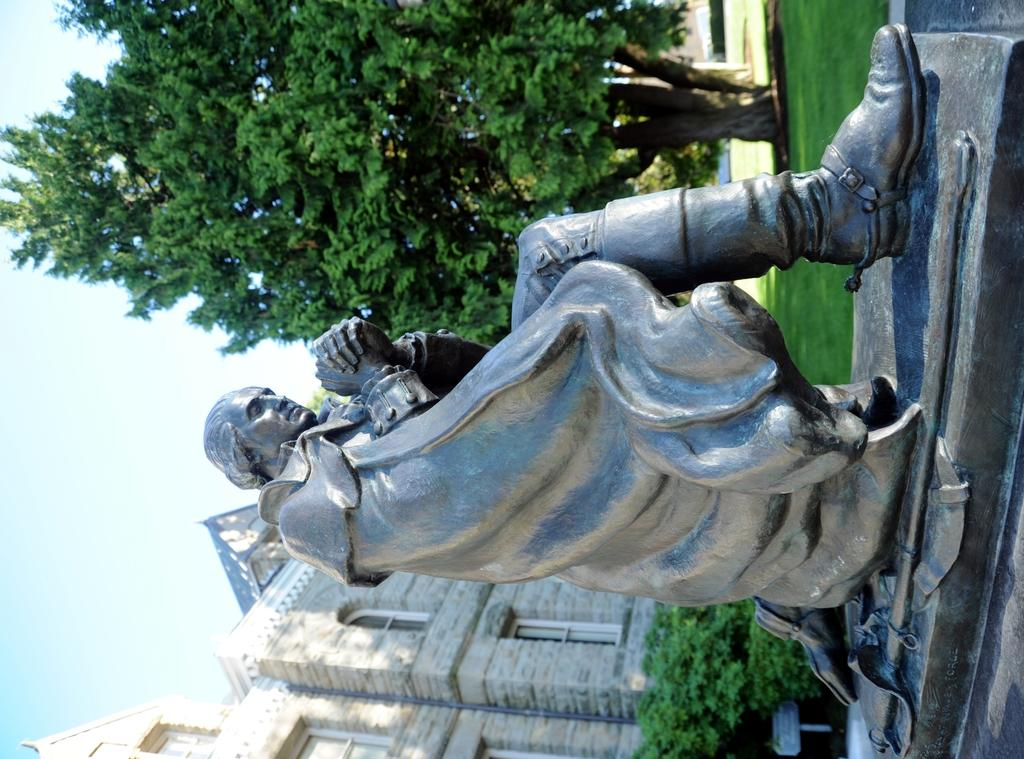What is the main subject of the image? There is a statue of a man in the image. What type of vegetation can be seen in the image? There are bushes and a tree with branches and leaves in the image. What type of structure is visible in the image? There is a building with windows in the image. What is the ground covered with in the image? There is grass in the image. What color is the crayon being used by the statue in the image? There is no crayon present in the image, and the statue is not depicted as using one. 